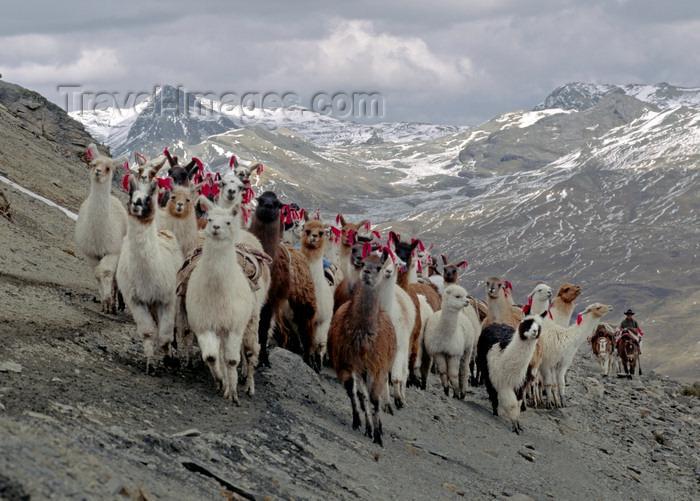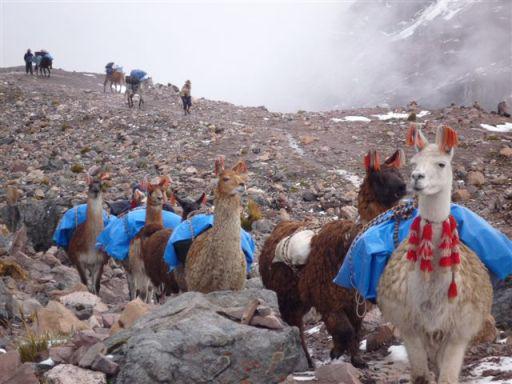The first image is the image on the left, the second image is the image on the right. Examine the images to the left and right. Is the description "The left image shows a small group of different colored llamas who aren't wearing anything, and the right image inludes at least one rightward-facing llama who is grazing." accurate? Answer yes or no. No. The first image is the image on the left, the second image is the image on the right. Examine the images to the left and right. Is the description "There are at least three llamas walking forward over big rocks." accurate? Answer yes or no. Yes. 